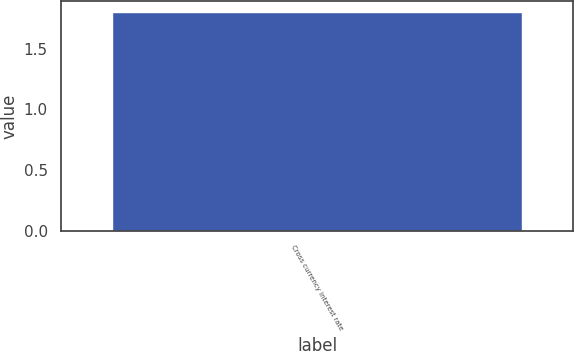Convert chart. <chart><loc_0><loc_0><loc_500><loc_500><bar_chart><fcel>Cross currency interest rate<nl><fcel>1.8<nl></chart> 